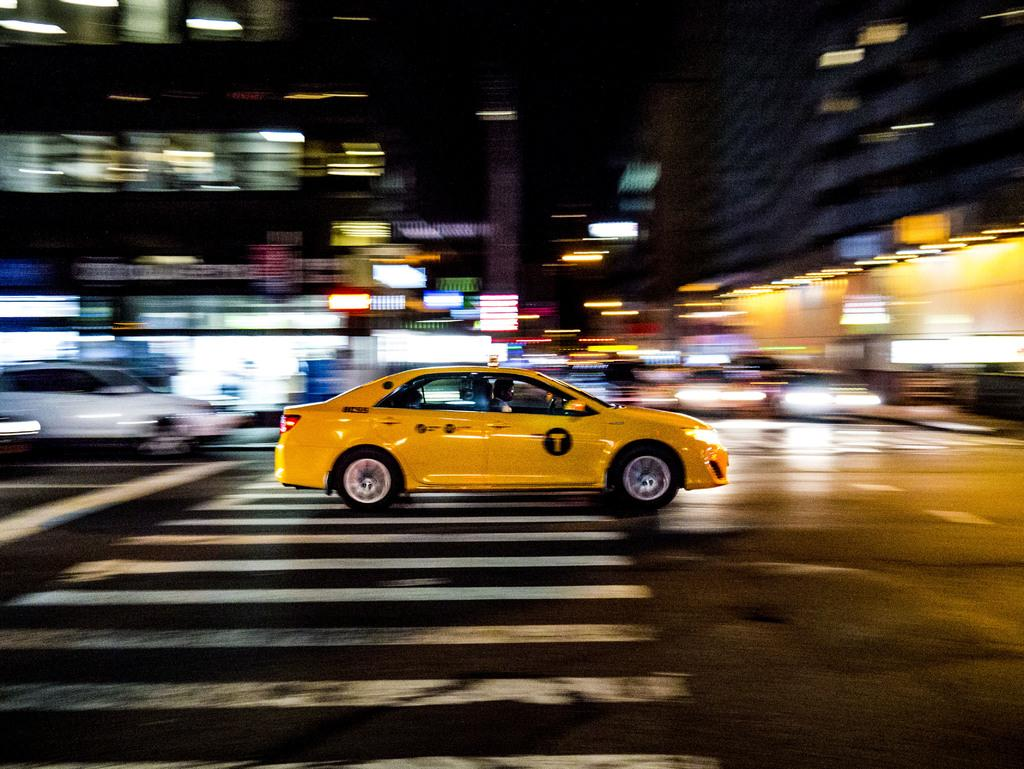<image>
Present a compact description of the photo's key features. A yellow car with a T on the side zooms down a street. 